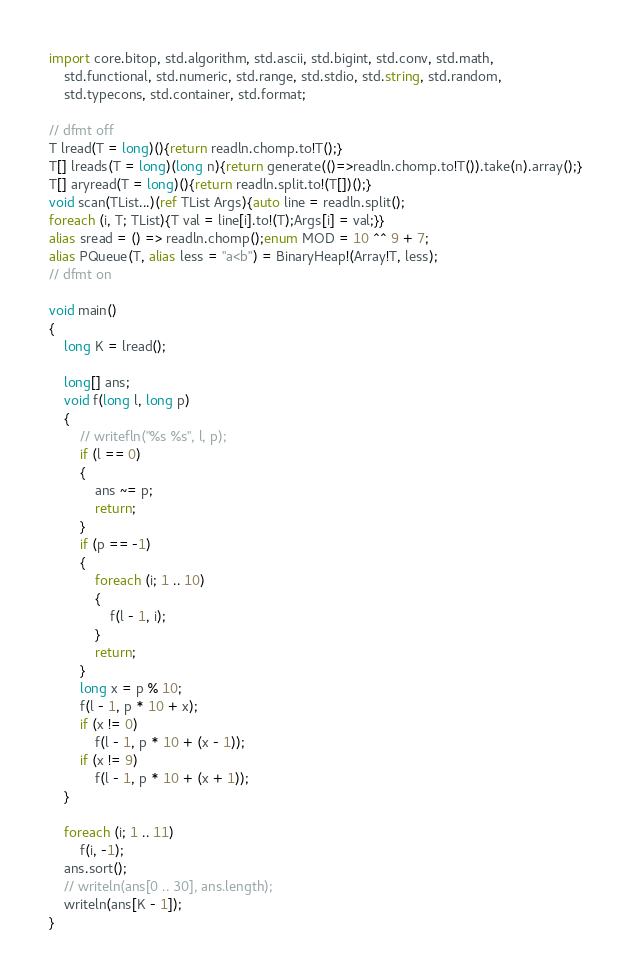Convert code to text. <code><loc_0><loc_0><loc_500><loc_500><_D_>import core.bitop, std.algorithm, std.ascii, std.bigint, std.conv, std.math,
    std.functional, std.numeric, std.range, std.stdio, std.string, std.random,
    std.typecons, std.container, std.format;

// dfmt off
T lread(T = long)(){return readln.chomp.to!T();}
T[] lreads(T = long)(long n){return generate(()=>readln.chomp.to!T()).take(n).array();}
T[] aryread(T = long)(){return readln.split.to!(T[])();}
void scan(TList...)(ref TList Args){auto line = readln.split();
foreach (i, T; TList){T val = line[i].to!(T);Args[i] = val;}}
alias sread = () => readln.chomp();enum MOD = 10 ^^ 9 + 7;
alias PQueue(T, alias less = "a<b") = BinaryHeap!(Array!T, less);
// dfmt on

void main()
{
    long K = lread();

    long[] ans;
    void f(long l, long p)
    {
        // writefln("%s %s", l, p);
        if (l == 0)
        {
            ans ~= p;
            return;
        }
        if (p == -1)
        {
            foreach (i; 1 .. 10)
            {
                f(l - 1, i);
            }
            return;
        }
        long x = p % 10;
        f(l - 1, p * 10 + x);
        if (x != 0)
            f(l - 1, p * 10 + (x - 1));
        if (x != 9)
            f(l - 1, p * 10 + (x + 1));
    }

    foreach (i; 1 .. 11)
        f(i, -1);
    ans.sort();
    // writeln(ans[0 .. 30], ans.length);
    writeln(ans[K - 1]);
}
</code> 